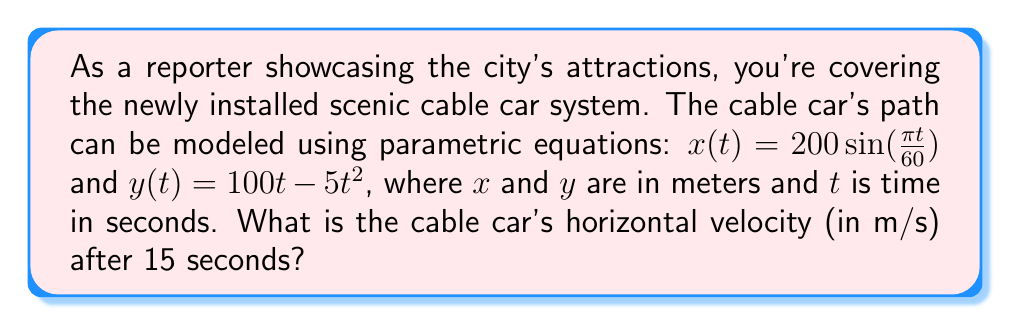Can you answer this question? To solve this problem, we need to follow these steps:

1) The horizontal velocity is given by the derivative of the x-component with respect to time. We need to find $\frac{dx}{dt}$.

2) Given: $x(t) = 200\sin(\frac{\pi t}{60})$

3) Using the chain rule to differentiate:

   $$\frac{dx}{dt} = 200 \cdot \cos(\frac{\pi t}{60}) \cdot \frac{\pi}{60}$$

4) Simplify:

   $$\frac{dx}{dt} = \frac{10\pi}{3} \cos(\frac{\pi t}{60})$$

5) We need to evaluate this at t = 15 seconds:

   $$\frac{dx}{dt}\bigg|_{t=15} = \frac{10\pi}{3} \cos(\frac{\pi \cdot 15}{60})$$

6) Simplify the argument of cosine:

   $$\frac{dx}{dt}\bigg|_{t=15} = \frac{10\pi}{3} \cos(\frac{\pi}{4})$$

7) We know that $\cos(\frac{\pi}{4}) = \frac{\sqrt{2}}{2}$

8) Therefore:

   $$\frac{dx}{dt}\bigg|_{t=15} = \frac{10\pi}{3} \cdot \frac{\sqrt{2}}{2} = \frac{5\pi\sqrt{2}}{3}$$

9) Calculate the final value:

   $$\frac{dx}{dt}\bigg|_{t=15} \approx 7.41 \text{ m/s}$$
Answer: The cable car's horizontal velocity after 15 seconds is approximately 7.41 m/s. 